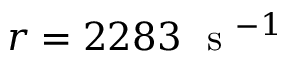Convert formula to latex. <formula><loc_0><loc_0><loc_500><loc_500>r = 2 2 8 3 s ^ { - 1 }</formula> 